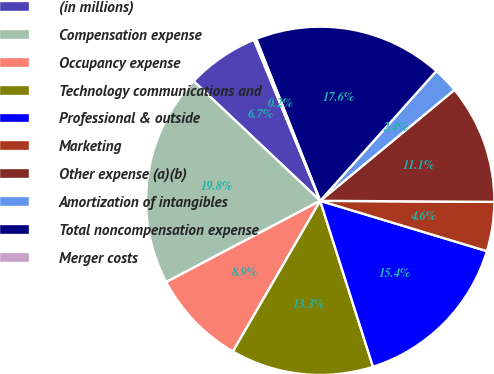<chart> <loc_0><loc_0><loc_500><loc_500><pie_chart><fcel>(in millions)<fcel>Compensation expense<fcel>Occupancy expense<fcel>Technology communications and<fcel>Professional & outside<fcel>Marketing<fcel>Other expense (a)(b)<fcel>Amortization of intangibles<fcel>Total noncompensation expense<fcel>Merger costs<nl><fcel>6.74%<fcel>19.78%<fcel>8.91%<fcel>13.26%<fcel>15.43%<fcel>4.57%<fcel>11.09%<fcel>2.39%<fcel>17.61%<fcel>0.22%<nl></chart> 